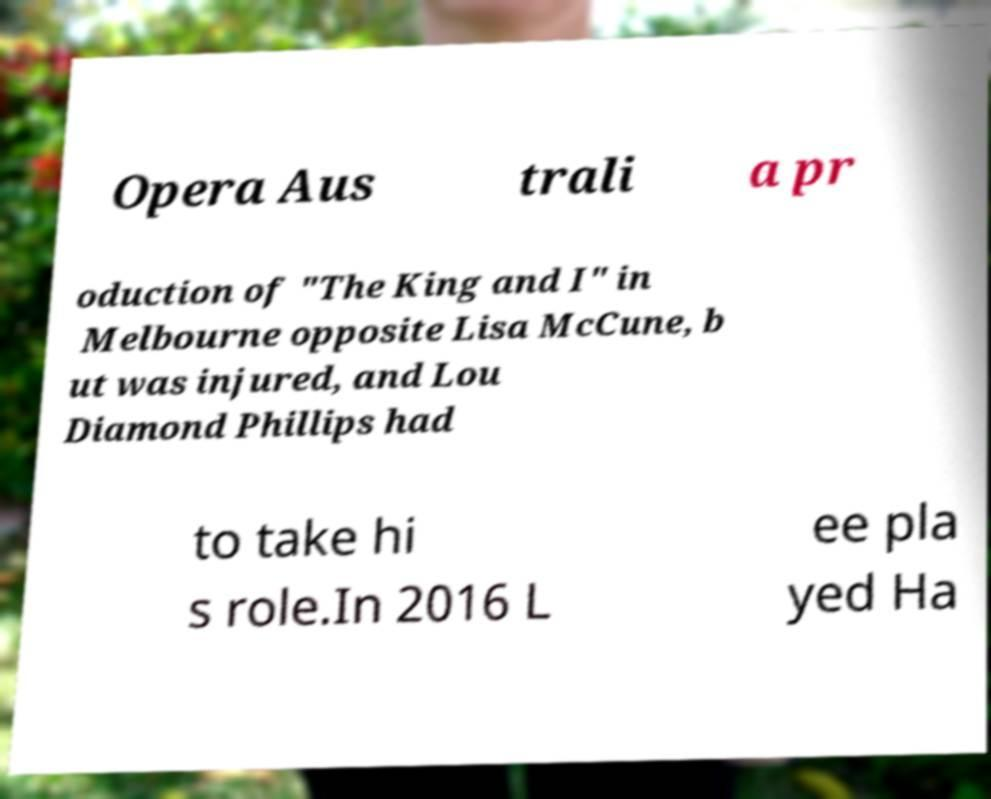Please read and relay the text visible in this image. What does it say? Opera Aus trali a pr oduction of "The King and I" in Melbourne opposite Lisa McCune, b ut was injured, and Lou Diamond Phillips had to take hi s role.In 2016 L ee pla yed Ha 